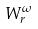<formula> <loc_0><loc_0><loc_500><loc_500>W _ { r } ^ { \omega }</formula> 